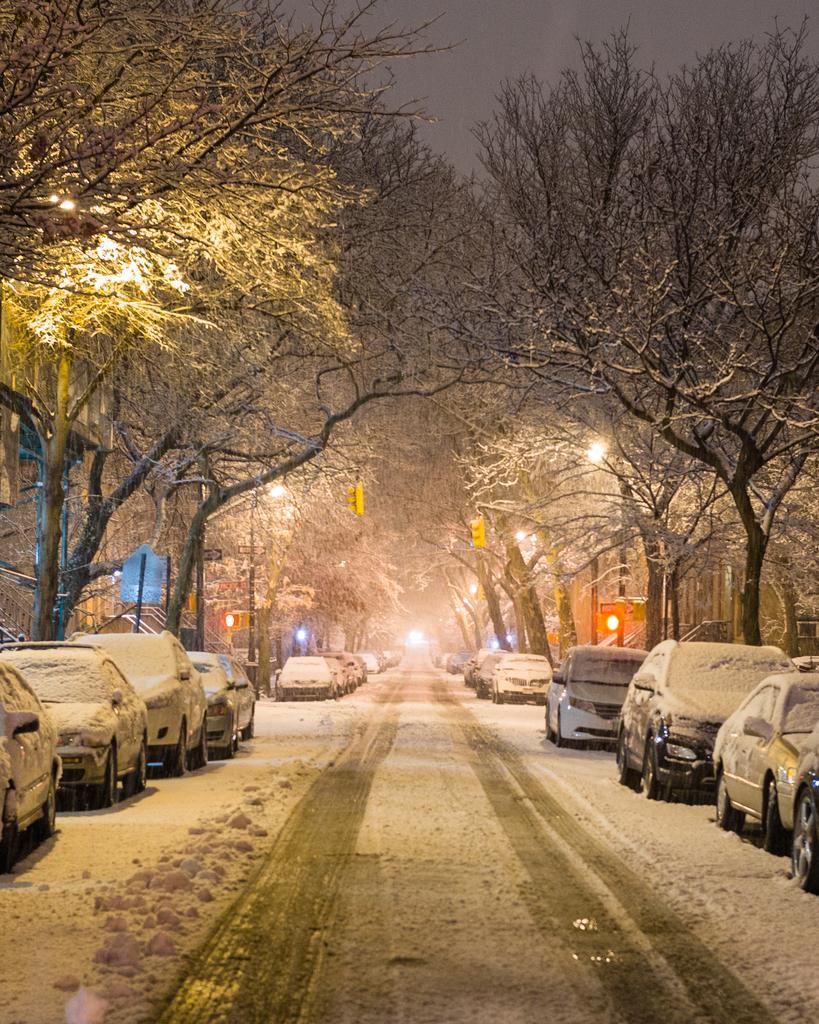Please provide a concise description of this image. In this image, we can see trees, poles, lights, railings, buildings and vehicles are all covered by snow and at the bottom, there is road. At the top, there is sky. 